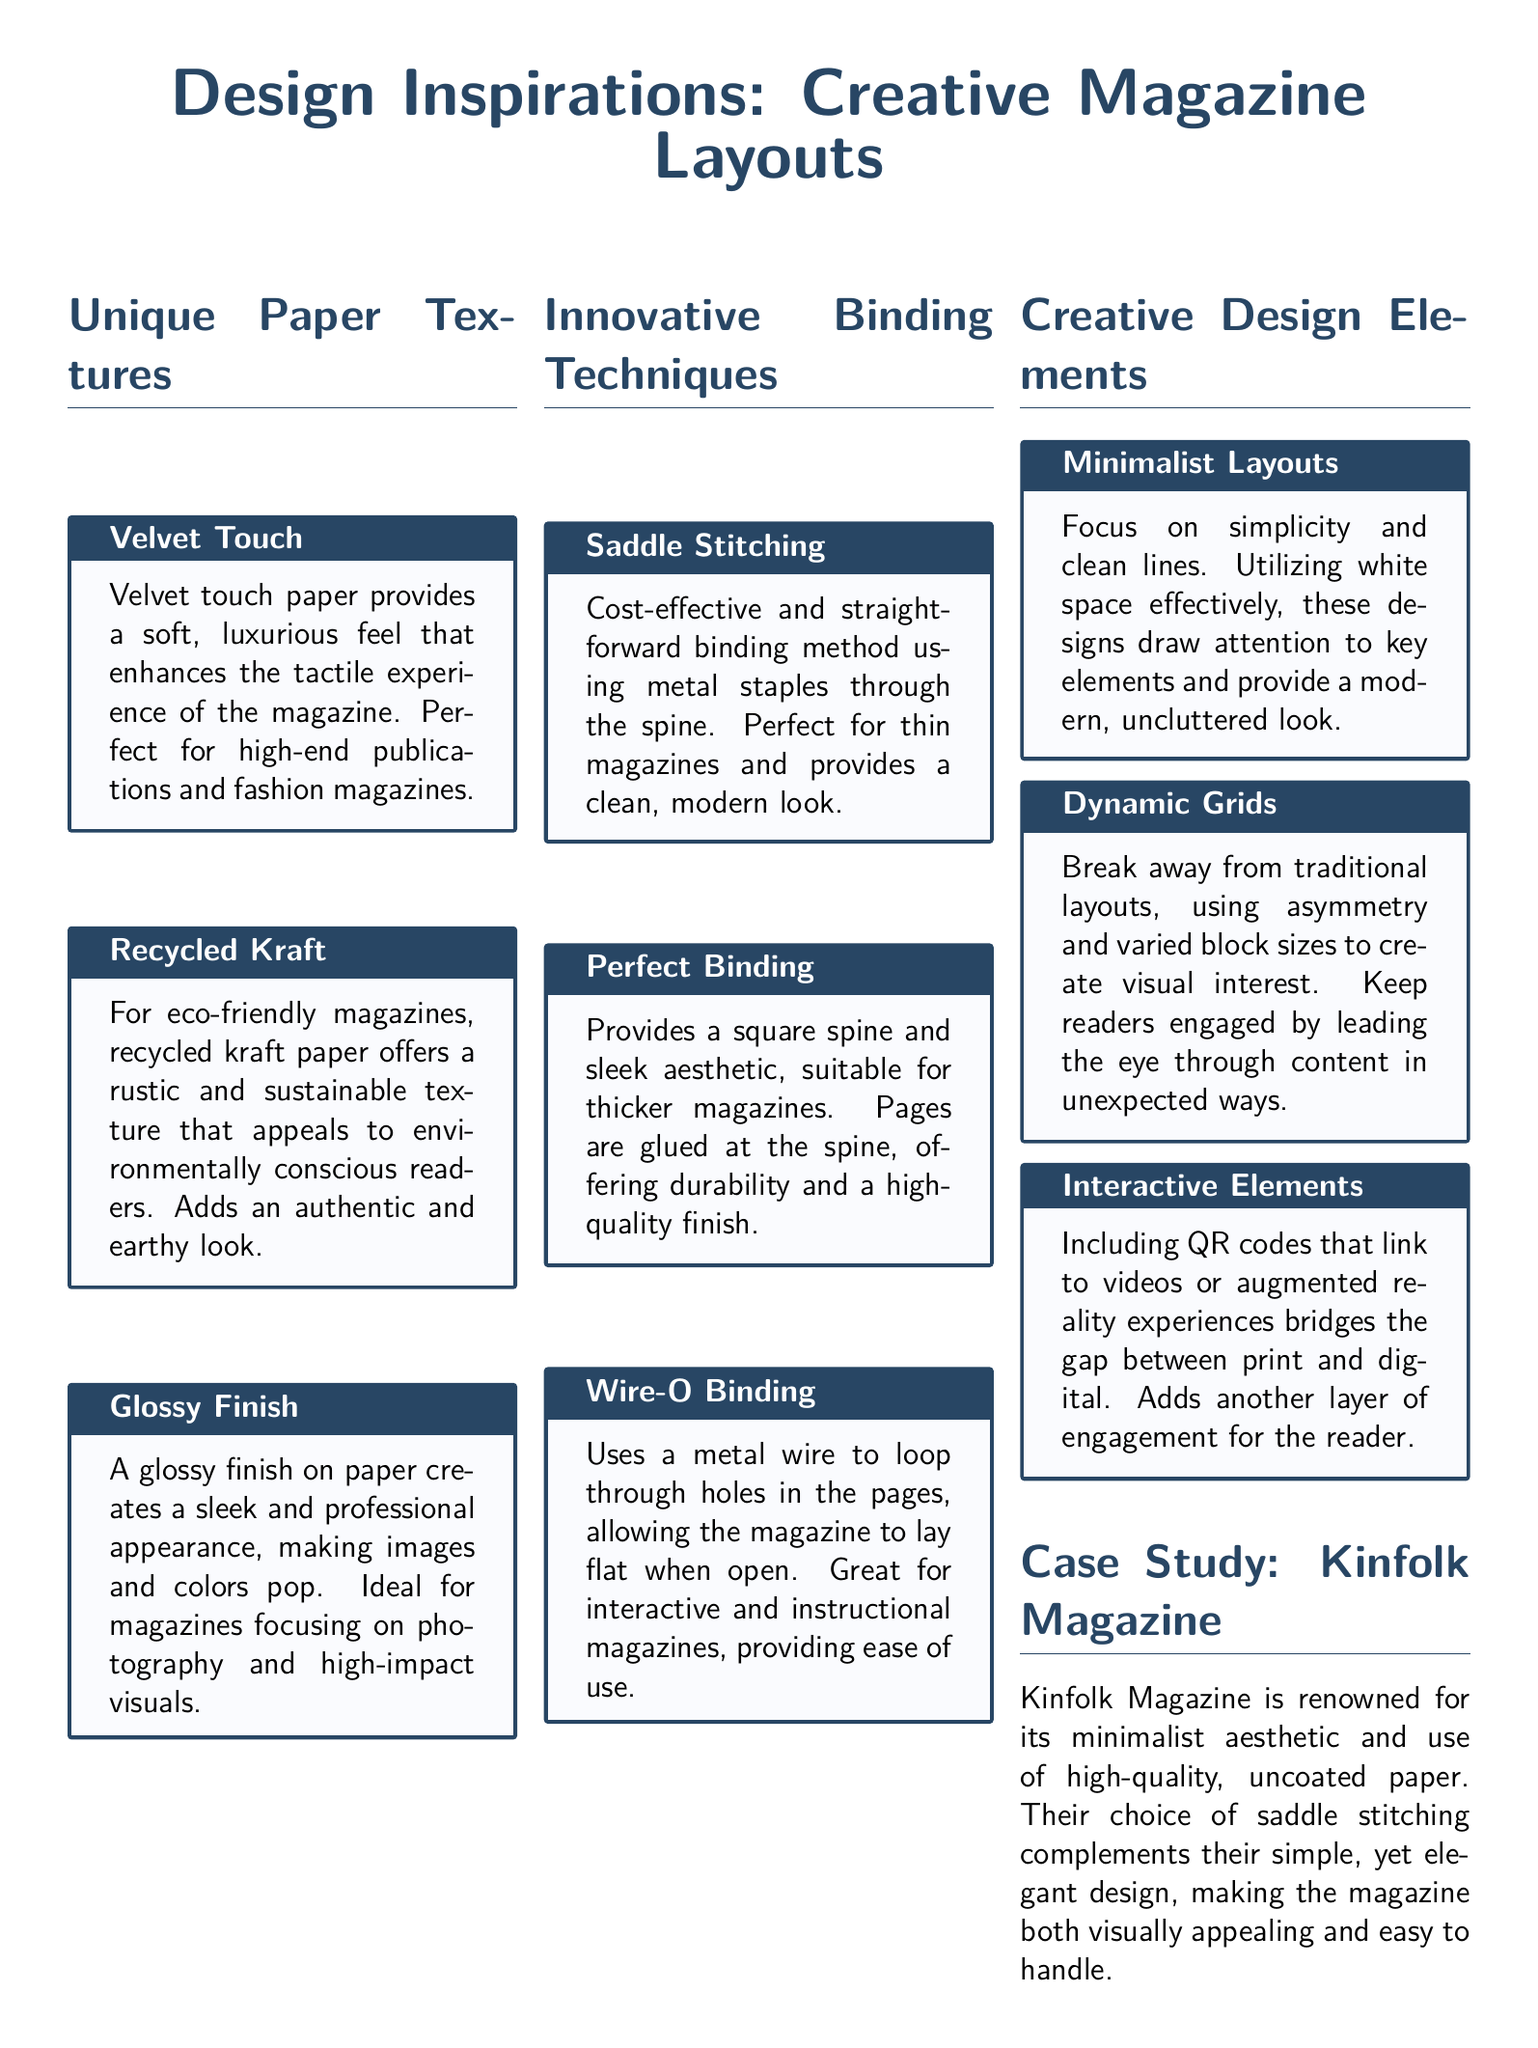What are the three unique paper textures mentioned? The document lists three unique paper textures: Velvet Touch, Recycled Kraft, and Glossy Finish.
Answer: Velvet Touch, Recycled Kraft, Glossy Finish What binding technique provides a square spine? The document indicates that Perfect Binding provides a square spine and a sleek aesthetic.
Answer: Perfect Binding What is a key feature of Wire-O Binding? The document states that Wire-O Binding allows the magazine to lay flat when open.
Answer: Lay flat Which magazine is highlighted in the case study? The document specifically mentions Kinfolk Magazine in the case study section.
Answer: Kinfolk Magazine What design approach uses simplicity and clean lines? The document describes Minimalist Layouts as a design approach that focuses on simplicity and clean lines.
Answer: Minimalist Layouts How does recycled kraft paper appeal to readers? The document explains that recycled kraft paper appeals to environmentally conscious readers, adding an authentic and earthy look.
Answer: Environmentally conscious readers How does the document categorize the layout inspirations? The document categorizes the layout inspirations into three sections: Unique Paper Textures, Innovative Binding Techniques, and Creative Design Elements.
Answer: Three sections What type of magazine is ideal for a glossy finish? The document mentions that a glossy finish is ideal for magazines focusing on photography and high-impact visuals.
Answer: Photography and high-impact visuals 